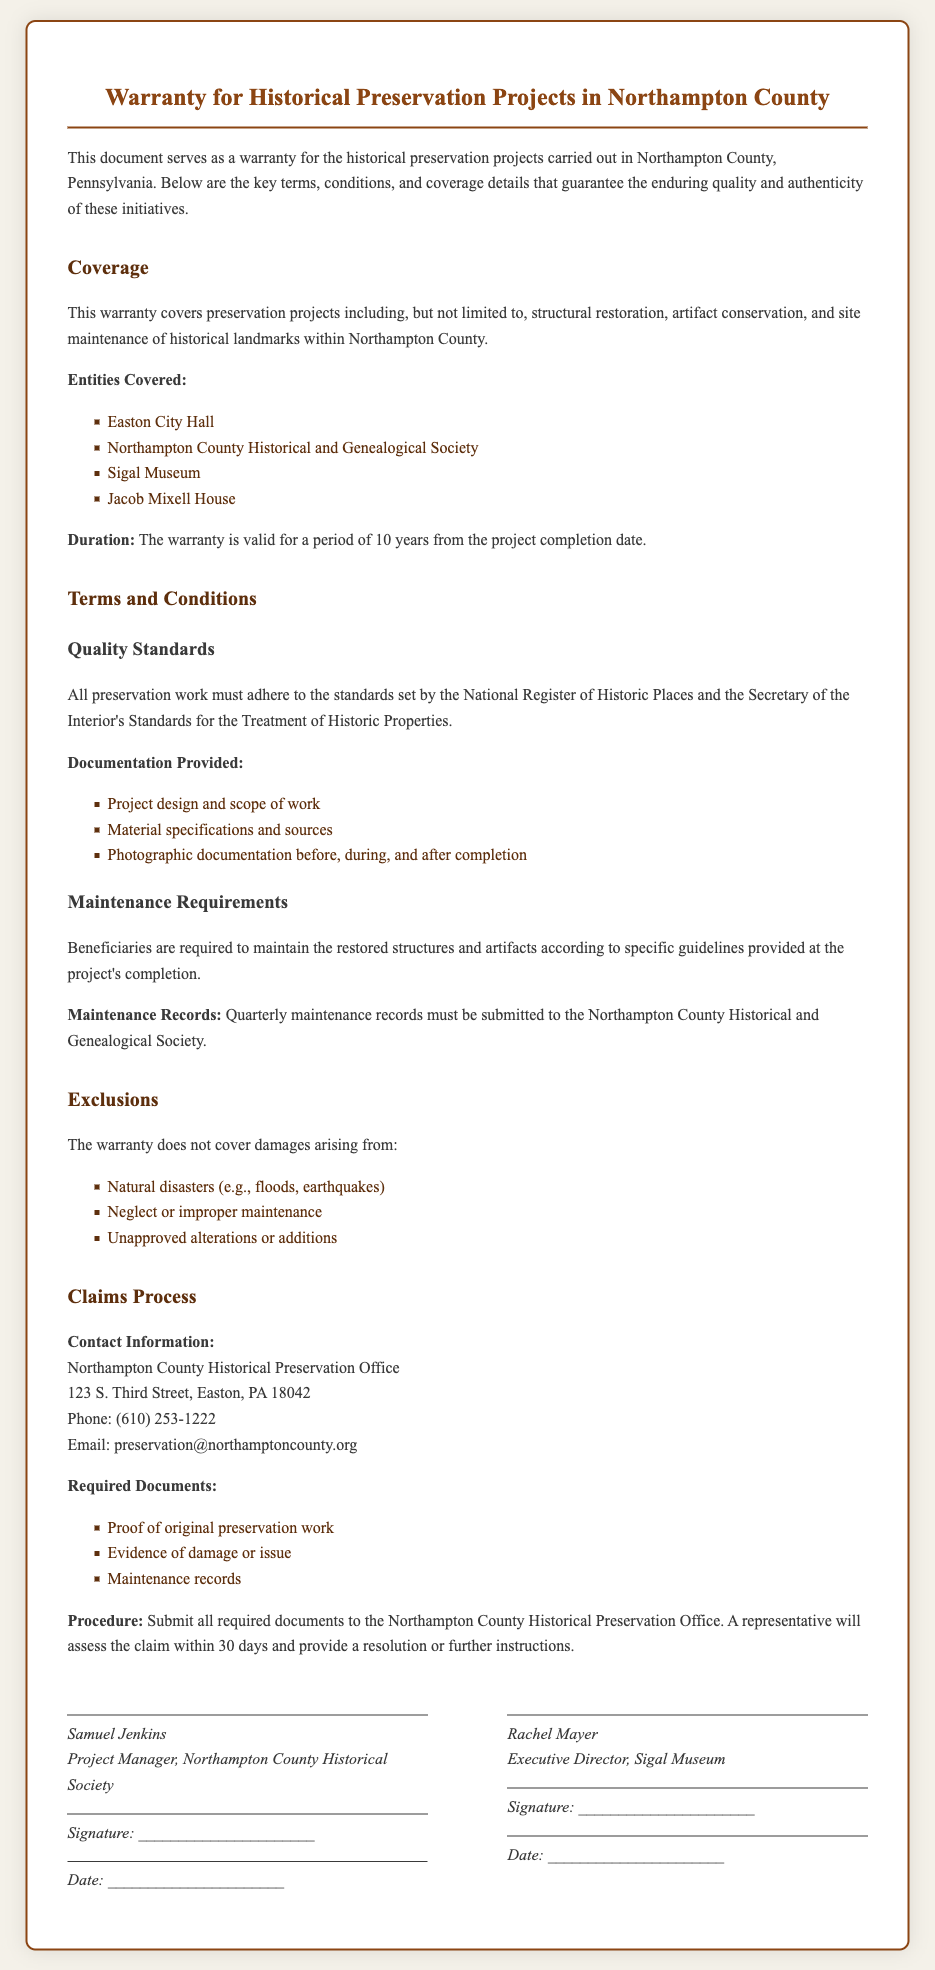What is the title of the document? The title of the document is the heading at the top, which encapsulates the main subject matter.
Answer: Warranty for Historical Preservation Projects in Northampton County What is the duration of the warranty? The duration is explicitly stated in the document under warranty details.
Answer: 10 years Which organizations are covered under this warranty? The document lists specific entities that are protected, indicating the scope of the warranty coverage.
Answer: Easton City Hall, Northampton County Historical and Genealogical Society, Sigal Museum, Jacob Mixell House Who is the Project Manager mentioned in the document? The name of the Project Manager is provided in the signature section, indicating who represents the warranty.
Answer: Samuel Jenkins What type of damages are excluded from the warranty? The document specifies certain situations where coverage is not applicable, outlining the limitations of the warranty.
Answer: Natural disasters, neglect or improper maintenance, unapproved alterations or additions What type of records must beneficiaries submit quarterly? The requirement for maintenance records is stated, indicating what is needed to maintain warranty coverage.
Answer: Maintenance records What is the claims processing office's phone number? This information is provided in the claims process section for easy contact regarding warranty claims.
Answer: 610-253-1222 What must be submitted along with a claim? The document outlines the required documents that need to be provided to pursue a warranty claim.
Answer: Proof of original preservation work, evidence of damage or issue, maintenance records 